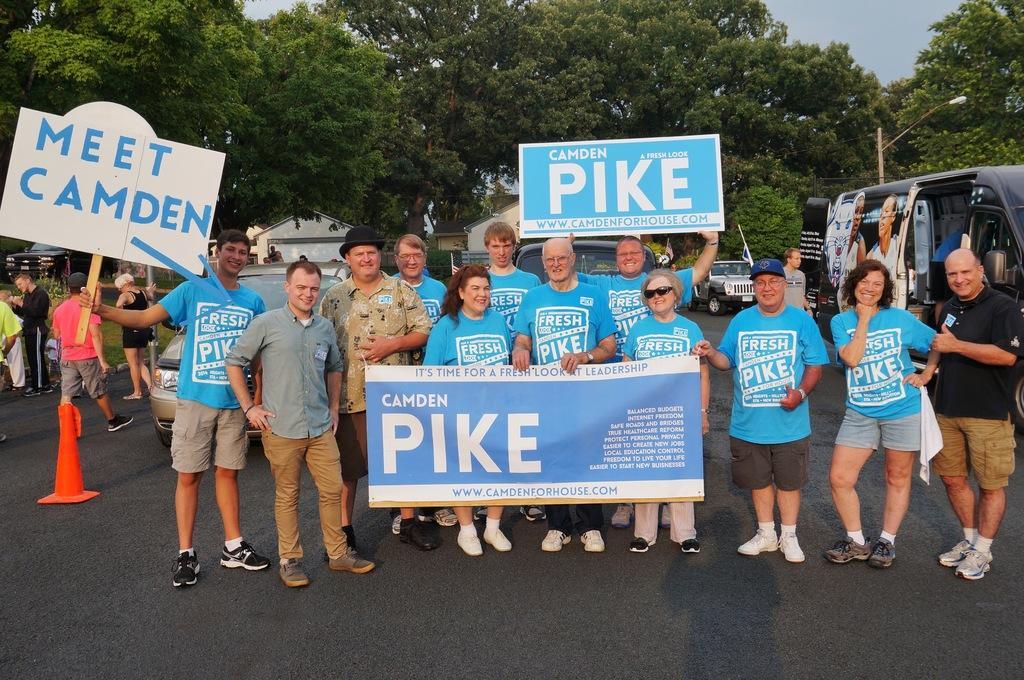Can you describe this image briefly? There are few persons standing on the road and among them few persons are holding hoardings and a banner in their hands. In the background there are vehicles, few persons, trees, buildings, light poles and sky. 